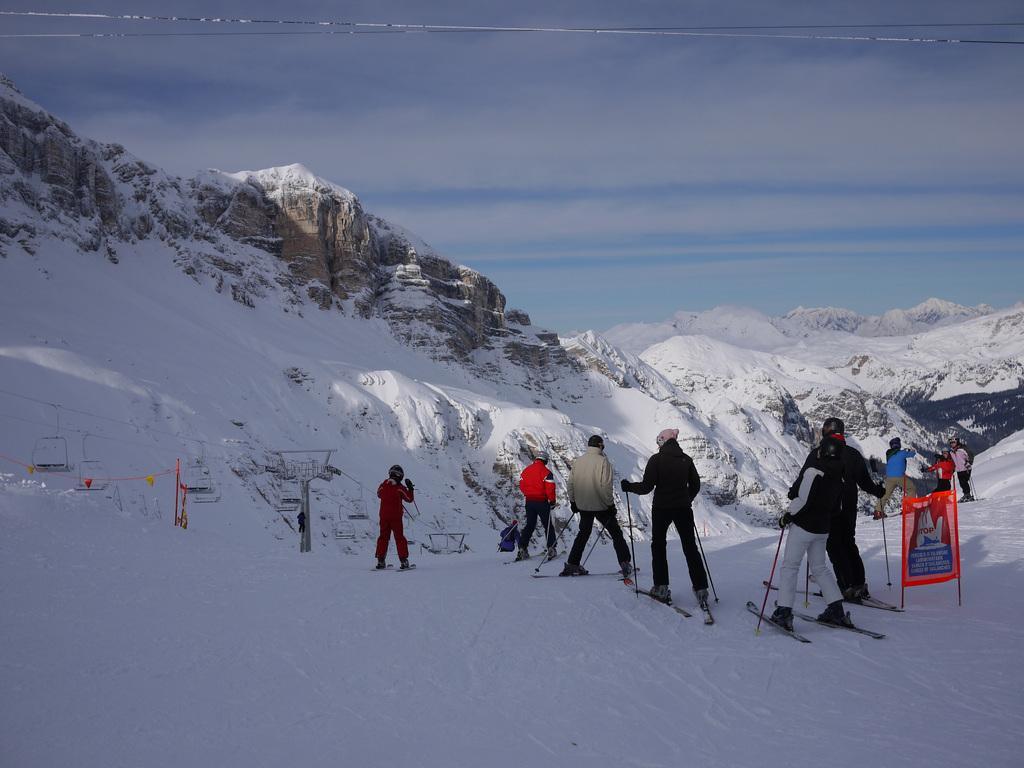Can you describe this image briefly? In this image we can see group of people wearing skis and helmets is holding sticks in their hands. In the right side of the image we can see a banner with some text. On the left side of the image we can see a rope way. In the background, we can see mountains and the cloudy sky. 